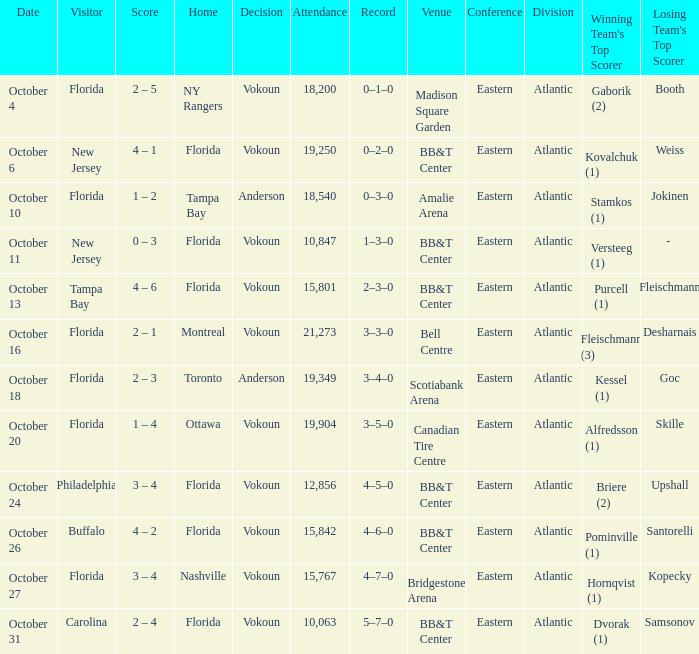Can you give me this table as a dict? {'header': ['Date', 'Visitor', 'Score', 'Home', 'Decision', 'Attendance', 'Record', 'Venue', 'Conference', 'Division', "Winning Team's Top Scorer", "Losing Team's Top Scorer"], 'rows': [['October 4', 'Florida', '2 – 5', 'NY Rangers', 'Vokoun', '18,200', '0–1–0', 'Madison Square Garden', 'Eastern', 'Atlantic', 'Gaborik (2)', 'Booth'], ['October 6', 'New Jersey', '4 – 1', 'Florida', 'Vokoun', '19,250', '0–2–0', 'BB&T Center', 'Eastern', 'Atlantic', 'Kovalchuk (1)', 'Weiss'], ['October 10', 'Florida', '1 – 2', 'Tampa Bay', 'Anderson', '18,540', '0–3–0', 'Amalie Arena', 'Eastern', 'Atlantic', 'Stamkos (1)', 'Jokinen'], ['October 11', 'New Jersey', '0 – 3', 'Florida', 'Vokoun', '10,847', '1–3–0', 'BB&T Center', 'Eastern', 'Atlantic', 'Versteeg (1)', '- '], ['October 13', 'Tampa Bay', '4 – 6', 'Florida', 'Vokoun', '15,801', '2–3–0', 'BB&T Center', 'Eastern', 'Atlantic', 'Purcell (1)', 'Fleischmann'], ['October 16', 'Florida', '2 – 1', 'Montreal', 'Vokoun', '21,273', '3–3–0', 'Bell Centre', 'Eastern', 'Atlantic', 'Fleischmann (3)', 'Desharnais'], ['October 18', 'Florida', '2 – 3', 'Toronto', 'Anderson', '19,349', '3–4–0', 'Scotiabank Arena', 'Eastern', 'Atlantic', 'Kessel (1)', 'Goc'], ['October 20', 'Florida', '1 – 4', 'Ottawa', 'Vokoun', '19,904', '3–5–0', 'Canadian Tire Centre', 'Eastern', 'Atlantic', 'Alfredsson (1)', 'Skille'], ['October 24', 'Philadelphia', '3 – 4', 'Florida', 'Vokoun', '12,856', '4–5–0', 'BB&T Center', 'Eastern', 'Atlantic', 'Briere (2)', 'Upshall'], ['October 26', 'Buffalo', '4 – 2', 'Florida', 'Vokoun', '15,842', '4–6–0', 'BB&T Center', 'Eastern', 'Atlantic', 'Pominville (1)', 'Santorelli'], ['October 27', 'Florida', '3 – 4', 'Nashville', 'Vokoun', '15,767', '4–7–0', 'Bridgestone Arena', 'Eastern', 'Atlantic', 'Hornqvist (1)', 'Kopecky'], ['October 31', 'Carolina', '2 – 4', 'Florida', 'Vokoun', '10,063', '5–7–0', 'BB&T Center', 'Eastern', 'Atlantic', 'Dvorak (1)', 'Samsonov']]} What was the result of the game on october 13? 4 – 6. 